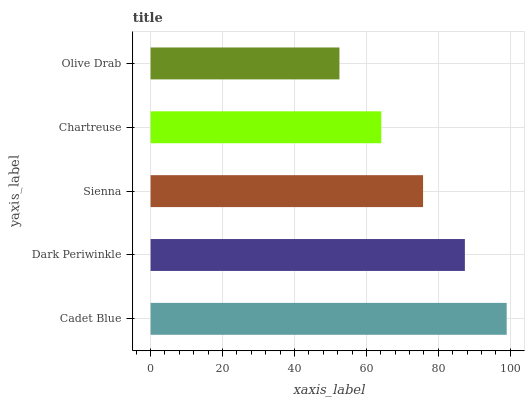Is Olive Drab the minimum?
Answer yes or no. Yes. Is Cadet Blue the maximum?
Answer yes or no. Yes. Is Dark Periwinkle the minimum?
Answer yes or no. No. Is Dark Periwinkle the maximum?
Answer yes or no. No. Is Cadet Blue greater than Dark Periwinkle?
Answer yes or no. Yes. Is Dark Periwinkle less than Cadet Blue?
Answer yes or no. Yes. Is Dark Periwinkle greater than Cadet Blue?
Answer yes or no. No. Is Cadet Blue less than Dark Periwinkle?
Answer yes or no. No. Is Sienna the high median?
Answer yes or no. Yes. Is Sienna the low median?
Answer yes or no. Yes. Is Dark Periwinkle the high median?
Answer yes or no. No. Is Dark Periwinkle the low median?
Answer yes or no. No. 